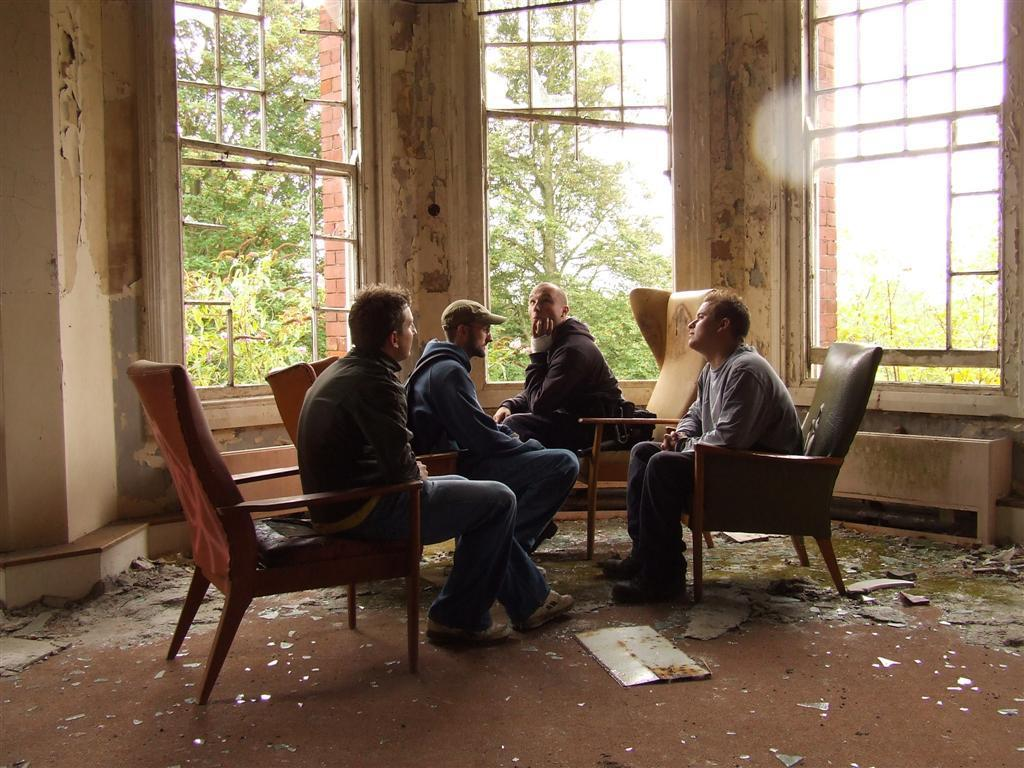How many people are present in the image? There are four people in the image. What are the people doing in the image? The people are sitting in a chair. What is the condition of the ground in the image? The ground is dirty. What can be seen through the windows in the image? The presence of windows suggests that there might be a view of the outdoors, but the specific view cannot be determined from the facts provided. What type of vegetation is near the people in the image? There are trees beside the people in the image. What type of kitty is sitting on the trade quiver in the image? There is no kitty or trade quiver present in the image. 